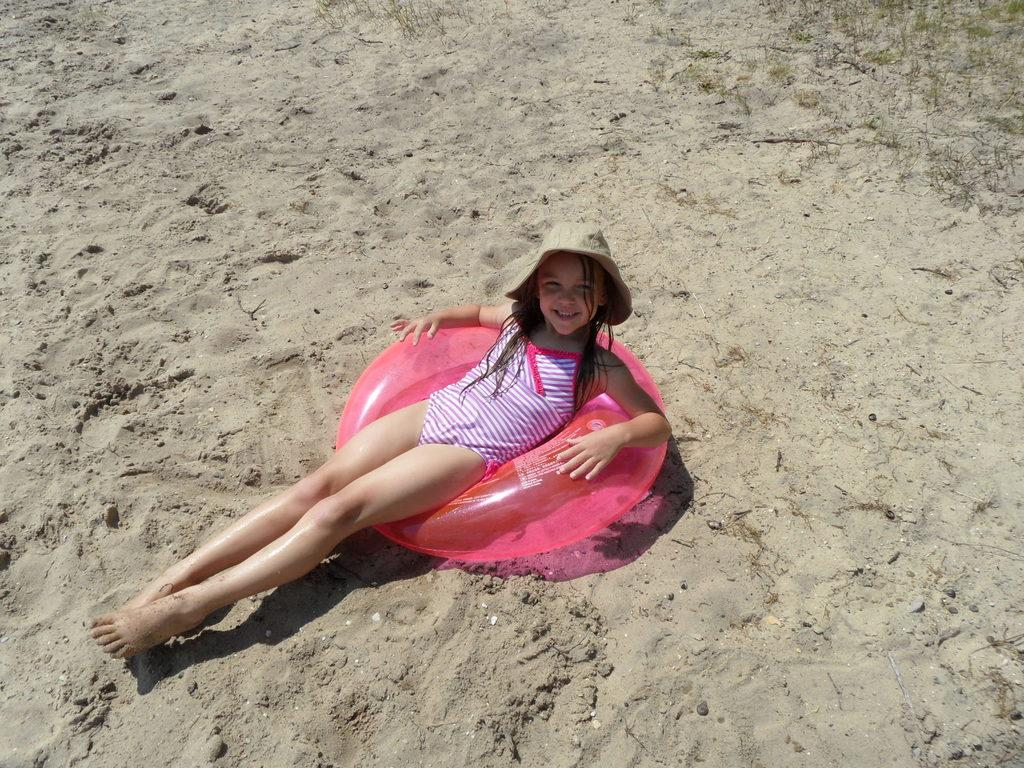Who is the main subject in the image? There is a girl in the center of the image. What is the girl doing in the image? The girl is lying down and smiling. What type of surface is the girl lying on? There is sand on the ground, and the girl is laying on a balloon that is on the ground. What type of wine is the girl holding in the image? There is no wine present in the image; the girl is lying down on a balloon on the sand. What is the aftermath of the bear attack in the image? There is no bear or bear attack present in the image; it features a girl lying on a balloon on the sand. 